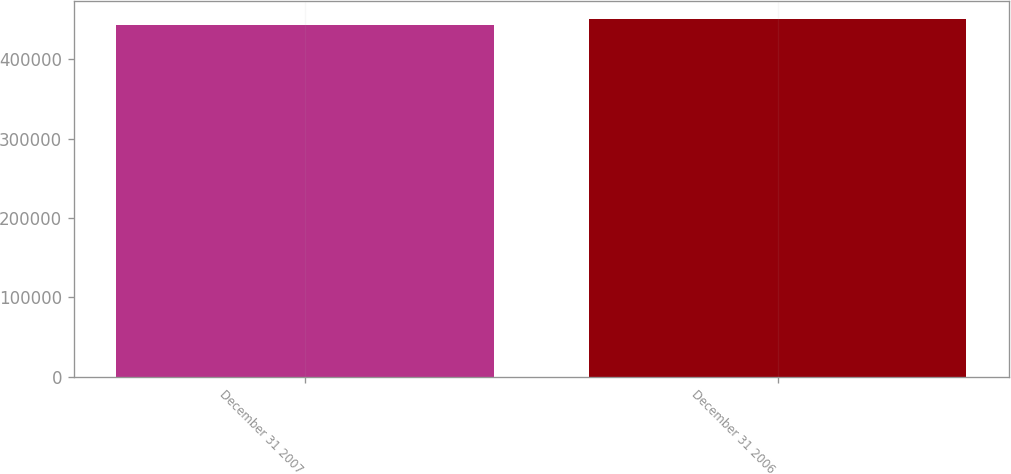Convert chart. <chart><loc_0><loc_0><loc_500><loc_500><bar_chart><fcel>December 31 2007<fcel>December 31 2006<nl><fcel>443048<fcel>450715<nl></chart> 